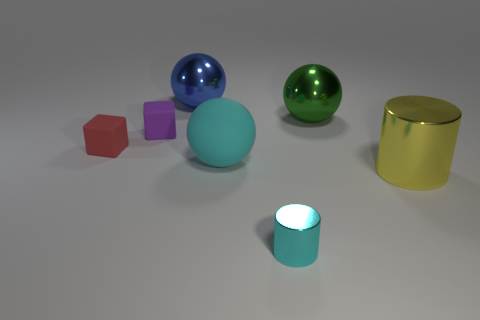There is a shiny object that is the same color as the matte sphere; what shape is it?
Provide a short and direct response. Cylinder. There is a object in front of the big metallic thing that is in front of the big green metallic thing; how many small metal cylinders are behind it?
Your answer should be very brief. 0. There is a rubber object that is on the right side of the large sphere left of the large cyan rubber thing; what is its size?
Your response must be concise. Large. The cyan object that is the same material as the purple object is what size?
Offer a very short reply. Large. There is a metallic object that is both behind the tiny purple object and to the left of the large green shiny object; what is its shape?
Your response must be concise. Sphere. Are there the same number of green metallic things that are in front of the green shiny thing and metal cubes?
Ensure brevity in your answer.  Yes. What number of objects are tiny red cubes or small objects that are on the left side of the tiny purple thing?
Ensure brevity in your answer.  1. Are there any other objects of the same shape as the small red object?
Your answer should be compact. Yes. Are there an equal number of metal cylinders that are behind the purple rubber thing and green metal balls that are in front of the red rubber object?
Give a very brief answer. Yes. Are there any other things that are the same size as the red block?
Ensure brevity in your answer.  Yes. 